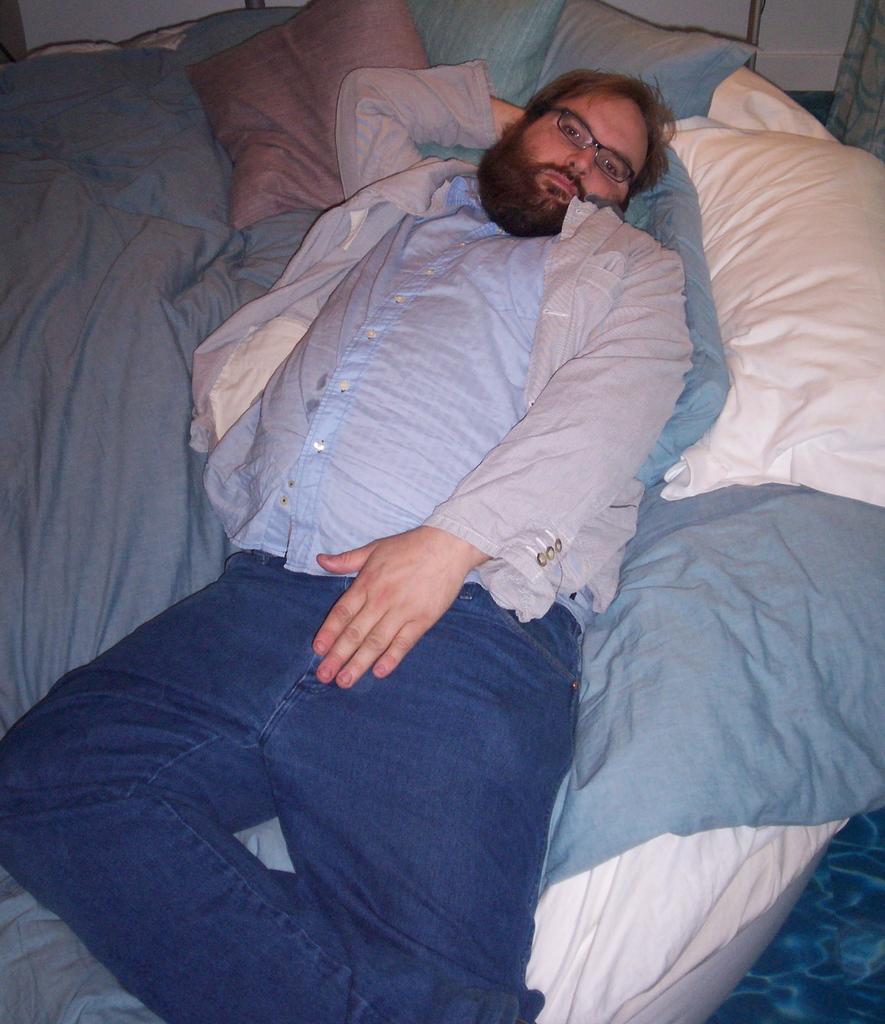Please provide a concise description of this image. A man is sleeping on the bed, he wore shirt, trouser, spectacles. 